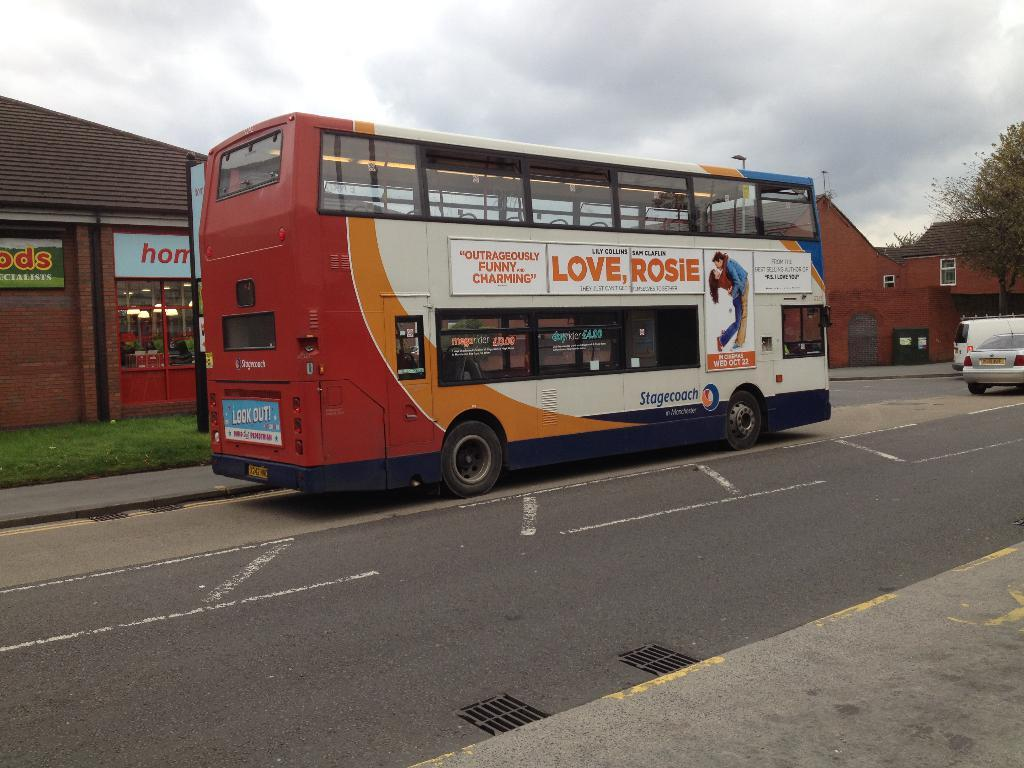<image>
Create a compact narrative representing the image presented. A double decker bus on a road with an advertisement for Love Rosie on the side. 